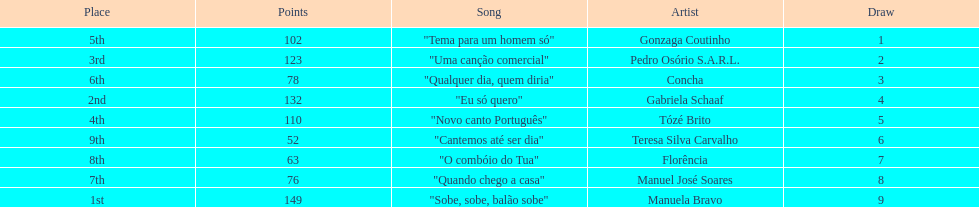Could you help me parse every detail presented in this table? {'header': ['Place', 'Points', 'Song', 'Artist', 'Draw'], 'rows': [['5th', '102', '"Tema para um homem só"', 'Gonzaga Coutinho', '1'], ['3rd', '123', '"Uma canção comercial"', 'Pedro Osório S.A.R.L.', '2'], ['6th', '78', '"Qualquer dia, quem diria"', 'Concha', '3'], ['2nd', '132', '"Eu só quero"', 'Gabriela Schaaf', '4'], ['4th', '110', '"Novo canto Português"', 'Tózé Brito', '5'], ['9th', '52', '"Cantemos até ser dia"', 'Teresa Silva Carvalho', '6'], ['8th', '63', '"O combóio do Tua"', 'Florência', '7'], ['7th', '76', '"Quando chego a casa"', 'Manuel José Soares', '8'], ['1st', '149', '"Sobe, sobe, balão sobe"', 'Manuela Bravo', '9']]} What is the total amount of points for florencia? 63. 